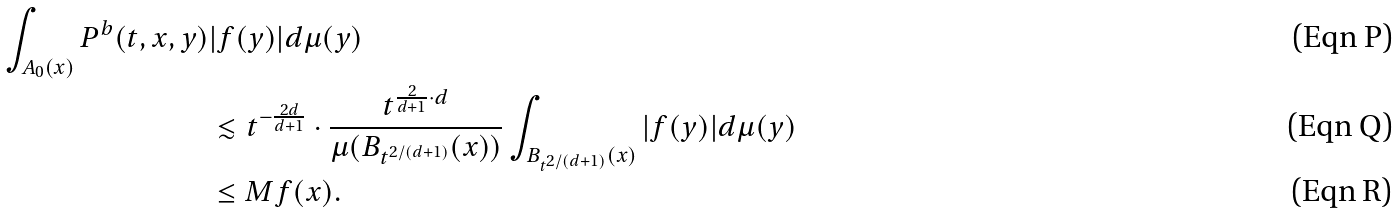<formula> <loc_0><loc_0><loc_500><loc_500>\int _ { A _ { 0 } ( x ) } P ^ { b } ( t , x , y ) & | f ( y ) | d \mu ( y ) \\ & \lesssim t ^ { - \frac { 2 d } { d + 1 } } \cdot \frac { t ^ { \frac { 2 } { d + 1 } \cdot d } } { \mu ( B _ { t ^ { 2 / ( d + 1 ) } } ( x ) ) } \int _ { B _ { t ^ { 2 / ( d + 1 ) } } ( x ) } | f ( y ) | d \mu ( y ) \\ & \leq M f ( x ) .</formula> 